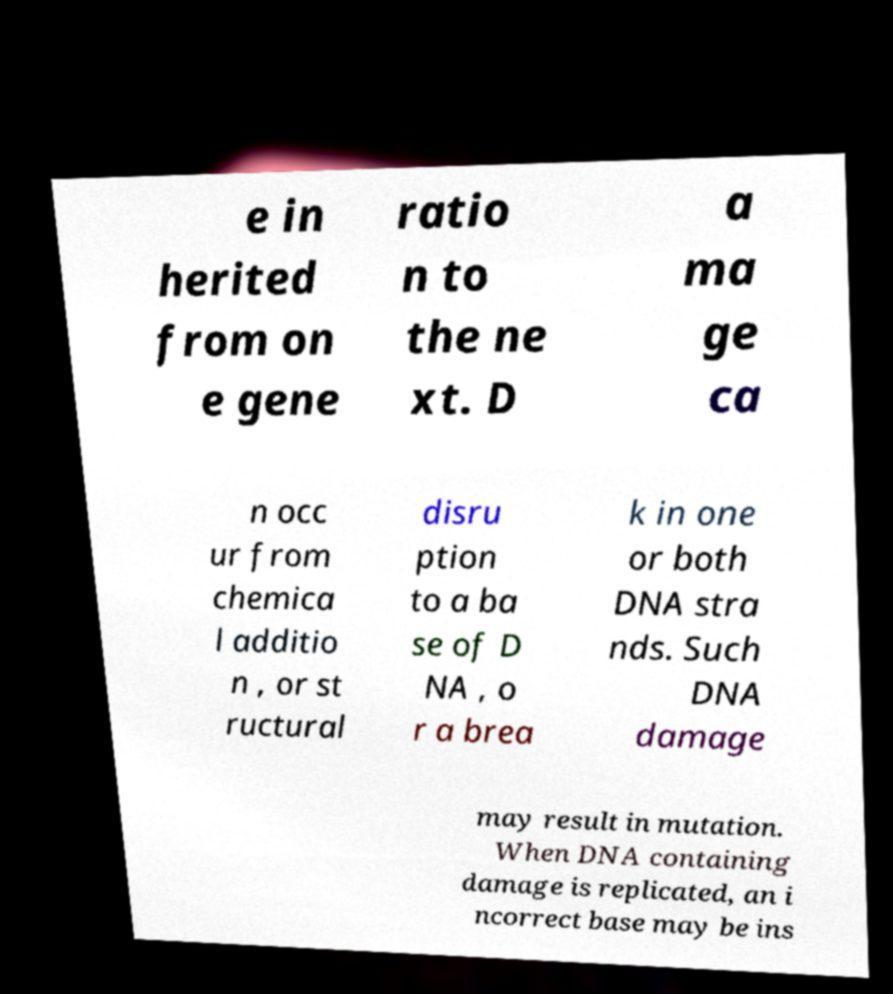Could you extract and type out the text from this image? e in herited from on e gene ratio n to the ne xt. D a ma ge ca n occ ur from chemica l additio n , or st ructural disru ption to a ba se of D NA , o r a brea k in one or both DNA stra nds. Such DNA damage may result in mutation. When DNA containing damage is replicated, an i ncorrect base may be ins 